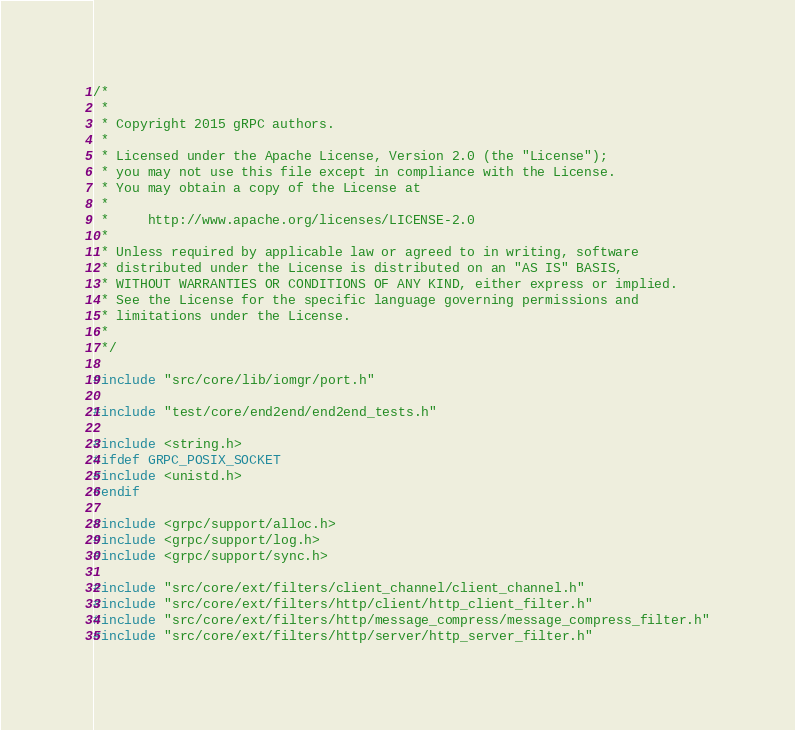Convert code to text. <code><loc_0><loc_0><loc_500><loc_500><_C++_>/*
 *
 * Copyright 2015 gRPC authors.
 *
 * Licensed under the Apache License, Version 2.0 (the "License");
 * you may not use this file except in compliance with the License.
 * You may obtain a copy of the License at
 *
 *     http://www.apache.org/licenses/LICENSE-2.0
 *
 * Unless required by applicable law or agreed to in writing, software
 * distributed under the License is distributed on an "AS IS" BASIS,
 * WITHOUT WARRANTIES OR CONDITIONS OF ANY KIND, either express or implied.
 * See the License for the specific language governing permissions and
 * limitations under the License.
 *
 */

#include "src/core/lib/iomgr/port.h"

#include "test/core/end2end/end2end_tests.h"

#include <string.h>
#ifdef GRPC_POSIX_SOCKET
#include <unistd.h>
#endif

#include <grpc/support/alloc.h>
#include <grpc/support/log.h>
#include <grpc/support/sync.h>

#include "src/core/ext/filters/client_channel/client_channel.h"
#include "src/core/ext/filters/http/client/http_client_filter.h"
#include "src/core/ext/filters/http/message_compress/message_compress_filter.h"
#include "src/core/ext/filters/http/server/http_server_filter.h"</code> 